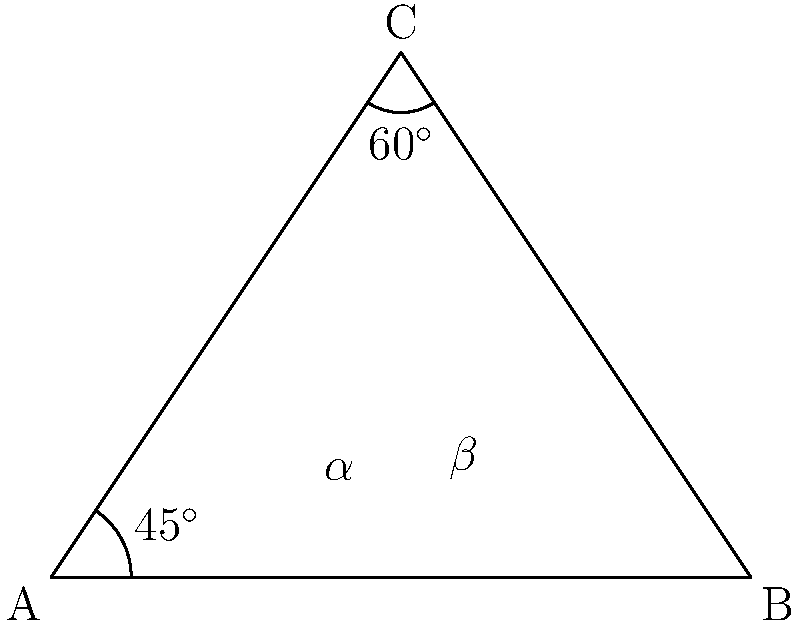In a high-end restaurant, two innovative chefs are presenting their dishes on triangular plates. The first chef's plating style forms an angle of $60^\circ$ with the base of the plate, while the second chef's style forms an angle of $45^\circ$ with the adjacent side. What is the angle between these two intersecting plating styles? Let's approach this step-by-step:

1) In the triangle ABC, we're given two angles:
   - Angle BCA = $60^\circ$
   - Angle BAC = $45^\circ$

2) We need to find the angle between AC and BC, which we'll call $\alpha + \beta$.

3) In any triangle, the sum of all angles is always $180^\circ$. So:
   $\angle BAC + \angle ABC + \angle BCA = 180^\circ$

4) We know two of these angles, so we can find the third:
   $45^\circ + \angle ABC + 60^\circ = 180^\circ$
   $\angle ABC = 180^\circ - 45^\circ - 60^\circ = 75^\circ$

5) Now, let's focus on the angles $\alpha$ and $\beta$:
   $\alpha + \beta + \angle ABC = 180^\circ$ (they form a straight line)

6) We can substitute what we know:
   $\alpha + \beta + 75^\circ = 180^\circ$

7) Solving for $\alpha + \beta$:
   $\alpha + \beta = 180^\circ - 75^\circ = 105^\circ$

Therefore, the angle between the two plating styles is $105^\circ$.
Answer: $105^\circ$ 